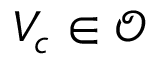Convert formula to latex. <formula><loc_0><loc_0><loc_500><loc_500>V _ { c } \in \mathcal { O }</formula> 